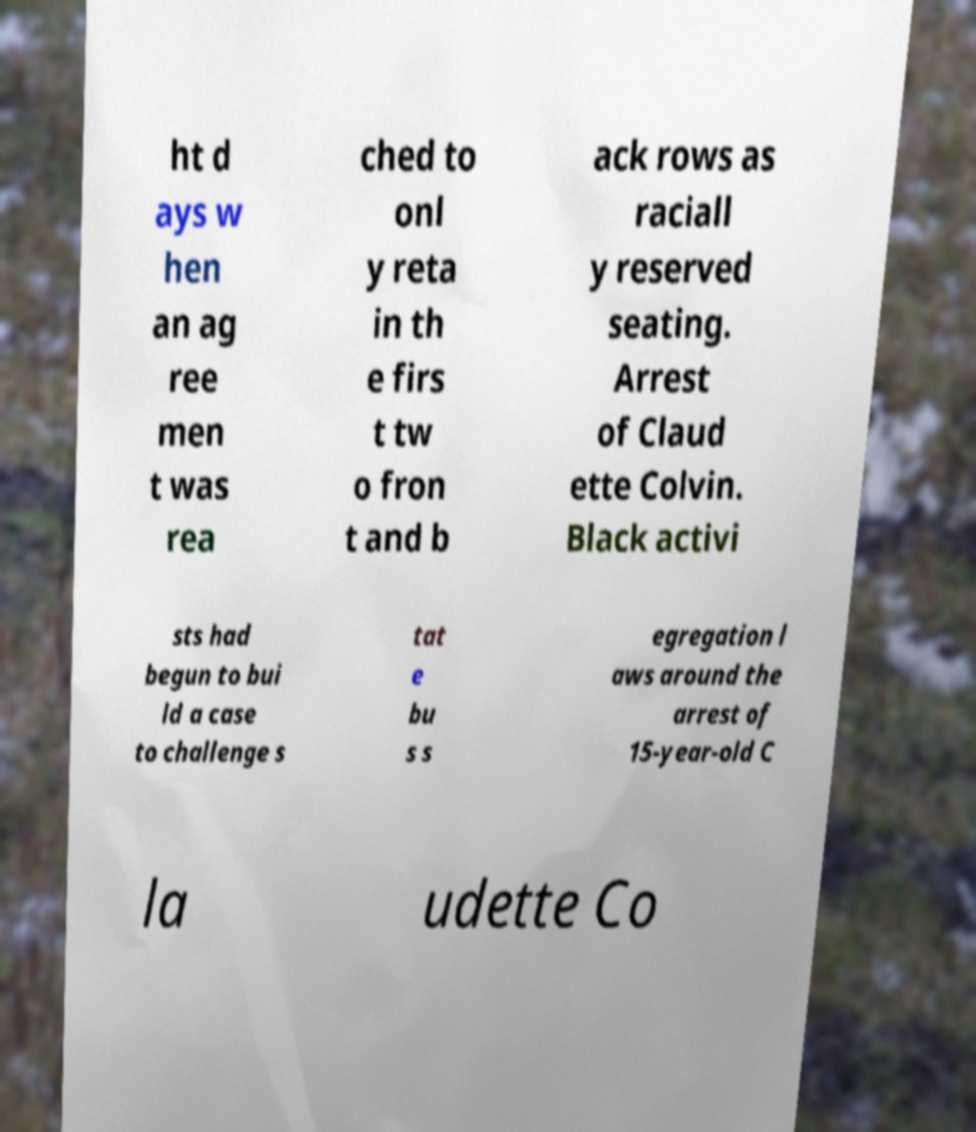Could you assist in decoding the text presented in this image and type it out clearly? ht d ays w hen an ag ree men t was rea ched to onl y reta in th e firs t tw o fron t and b ack rows as raciall y reserved seating. Arrest of Claud ette Colvin. Black activi sts had begun to bui ld a case to challenge s tat e bu s s egregation l aws around the arrest of 15-year-old C la udette Co 